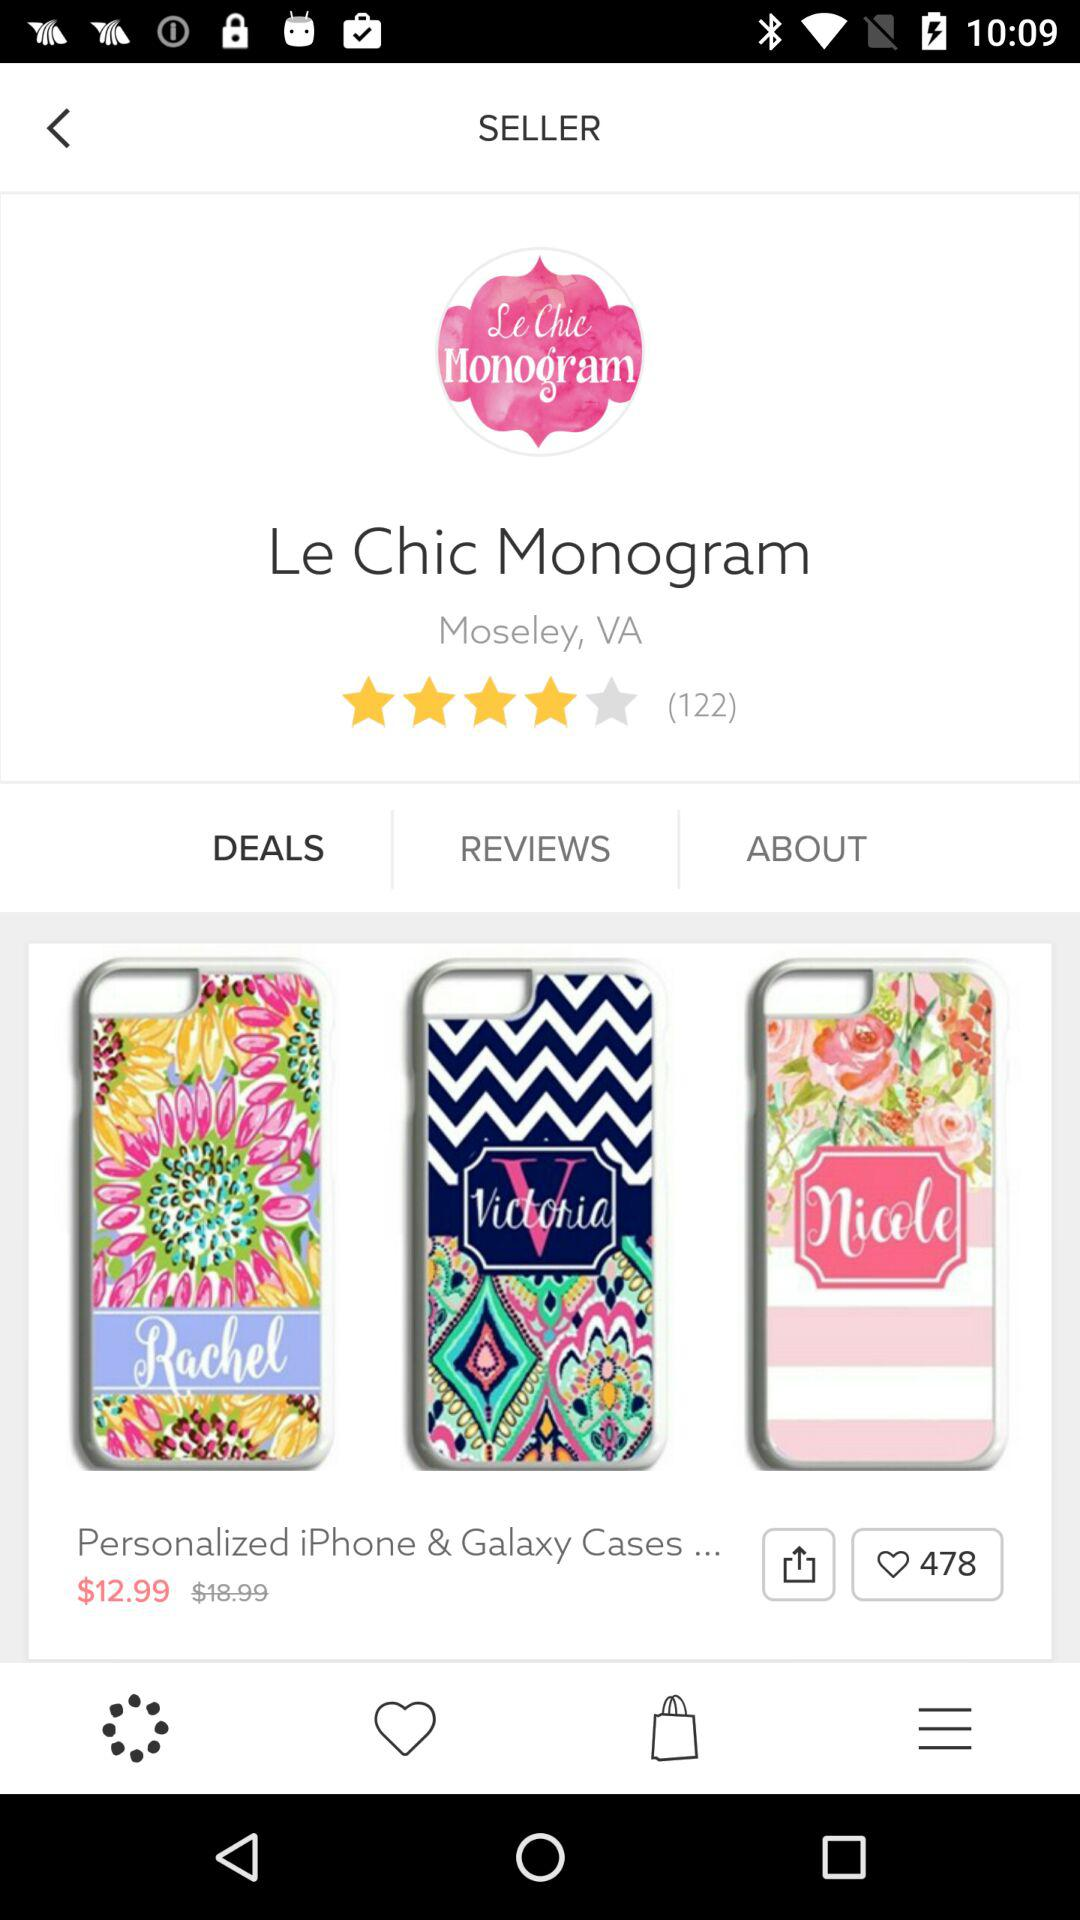What is the location? The location is Moseley, VA. 